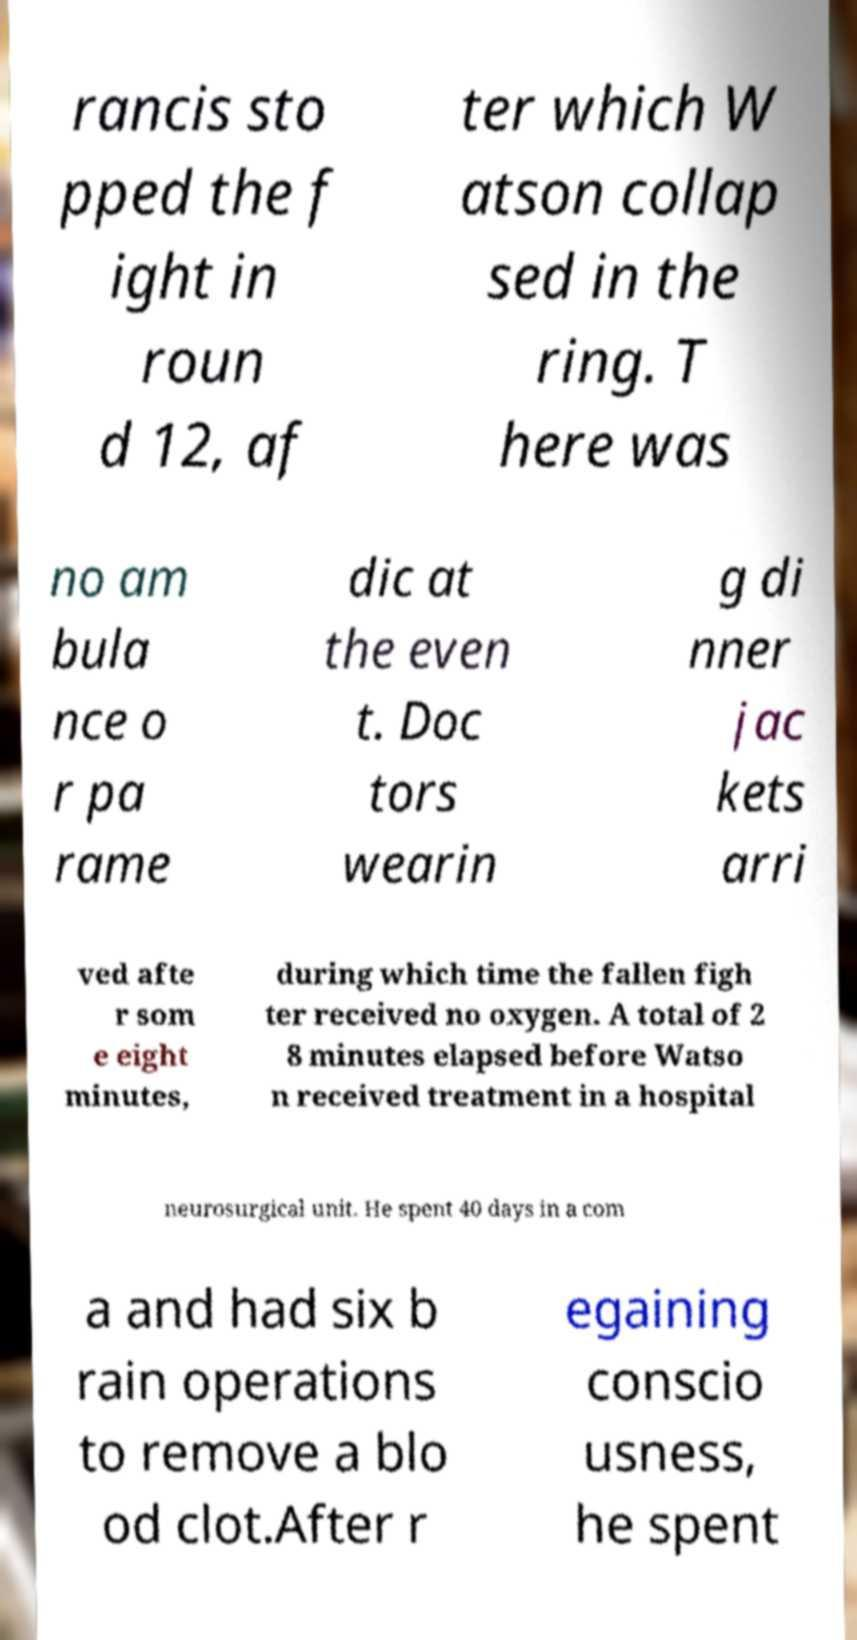Please identify and transcribe the text found in this image. rancis sto pped the f ight in roun d 12, af ter which W atson collap sed in the ring. T here was no am bula nce o r pa rame dic at the even t. Doc tors wearin g di nner jac kets arri ved afte r som e eight minutes, during which time the fallen figh ter received no oxygen. A total of 2 8 minutes elapsed before Watso n received treatment in a hospital neurosurgical unit. He spent 40 days in a com a and had six b rain operations to remove a blo od clot.After r egaining conscio usness, he spent 